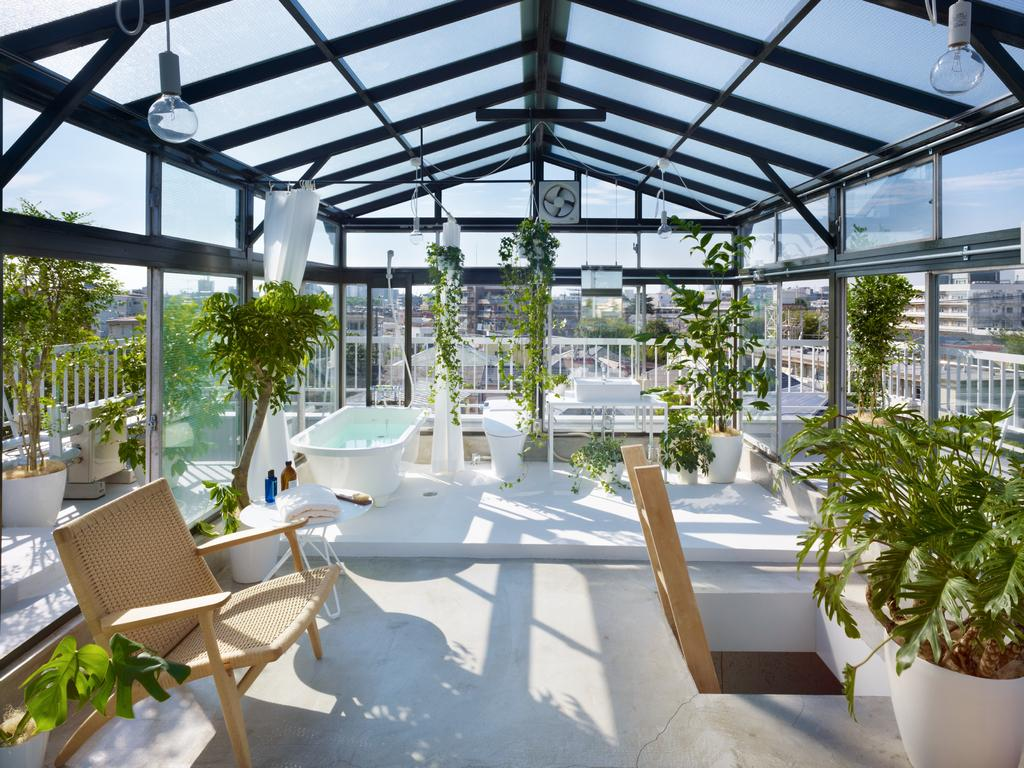What type of furniture is present in the image? There is a chair in the image. What type of vegetation can be seen in the image? There are plants in the image. What type of window treatment is present in the image? There are curtains in the image. What type of lighting is present in the image? There are bulbs in the image. What can be seen in the background of the image? There are buildings in the background of the image. Can you tell me how many cabbages are on the chair in the image? There are no cabbages present in the image; it features a chair, plants, curtains, bulbs, and buildings in the background. Is there a goat visible in the image? No, there is no goat present in the image. 